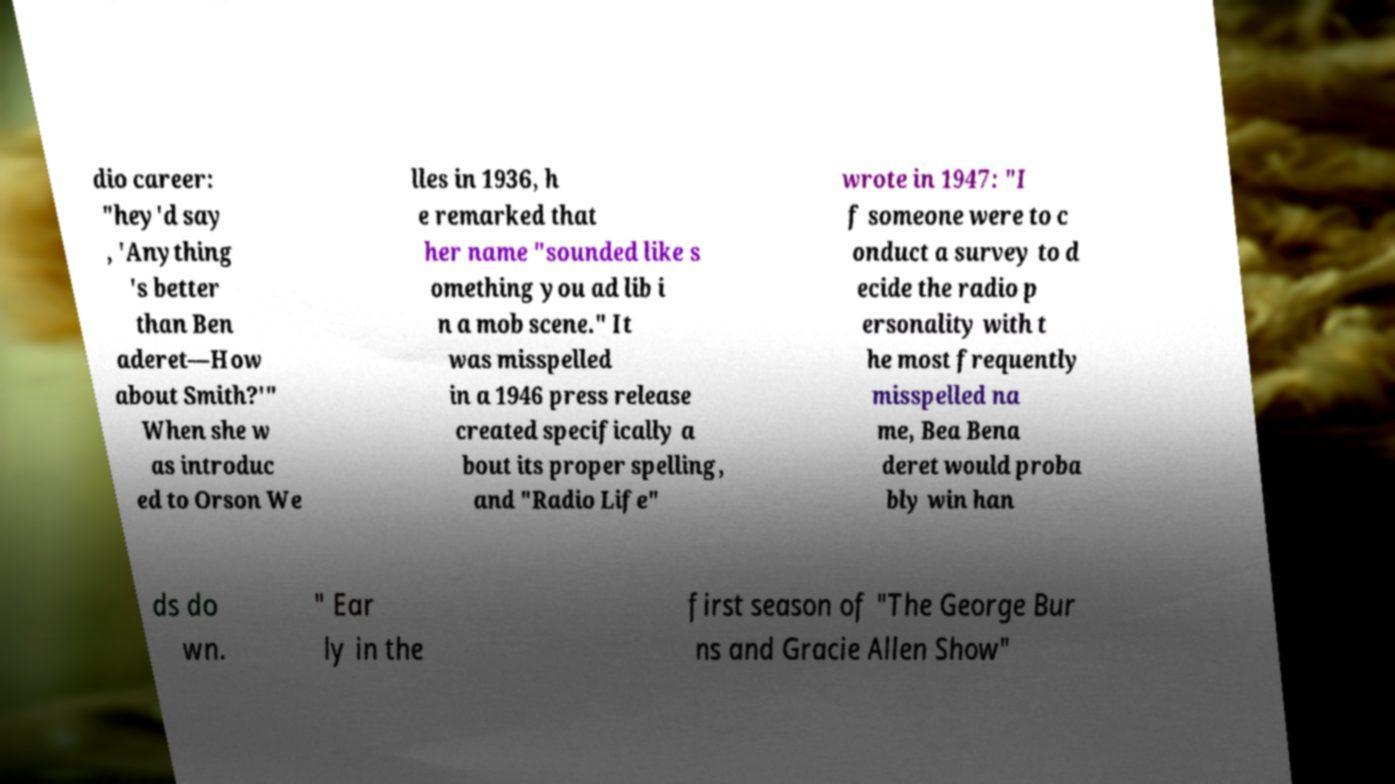Could you assist in decoding the text presented in this image and type it out clearly? dio career: "hey'd say , 'Anything 's better than Ben aderet—How about Smith?'" When she w as introduc ed to Orson We lles in 1936, h e remarked that her name "sounded like s omething you ad lib i n a mob scene." It was misspelled in a 1946 press release created specifically a bout its proper spelling, and "Radio Life" wrote in 1947: "I f someone were to c onduct a survey to d ecide the radio p ersonality with t he most frequently misspelled na me, Bea Bena deret would proba bly win han ds do wn. " Ear ly in the first season of "The George Bur ns and Gracie Allen Show" 